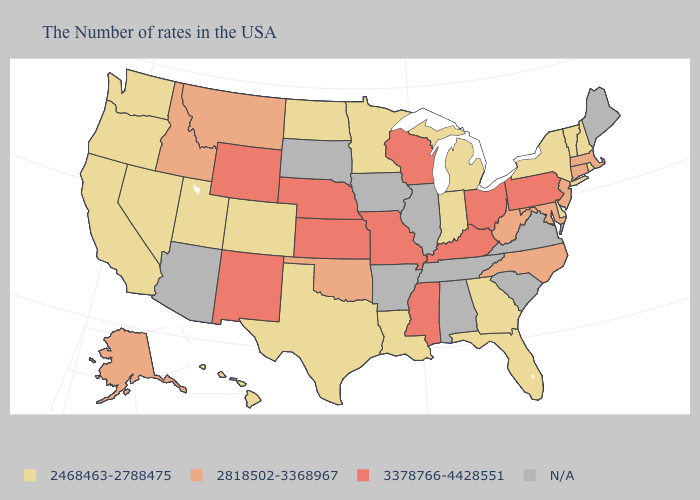Name the states that have a value in the range 3378766-4428551?
Be succinct. Pennsylvania, Ohio, Kentucky, Wisconsin, Mississippi, Missouri, Kansas, Nebraska, Wyoming, New Mexico. Name the states that have a value in the range 2468463-2788475?
Concise answer only. Rhode Island, New Hampshire, Vermont, New York, Delaware, Florida, Georgia, Michigan, Indiana, Louisiana, Minnesota, Texas, North Dakota, Colorado, Utah, Nevada, California, Washington, Oregon, Hawaii. What is the highest value in the USA?
Give a very brief answer. 3378766-4428551. What is the lowest value in states that border West Virginia?
Answer briefly. 2818502-3368967. What is the value of Nevada?
Quick response, please. 2468463-2788475. What is the value of Kansas?
Write a very short answer. 3378766-4428551. What is the lowest value in states that border Missouri?
Concise answer only. 2818502-3368967. Among the states that border California , which have the highest value?
Give a very brief answer. Nevada, Oregon. Does Colorado have the highest value in the USA?
Keep it brief. No. What is the highest value in the USA?
Write a very short answer. 3378766-4428551. What is the value of Utah?
Quick response, please. 2468463-2788475. How many symbols are there in the legend?
Quick response, please. 4. Does the map have missing data?
Answer briefly. Yes. 